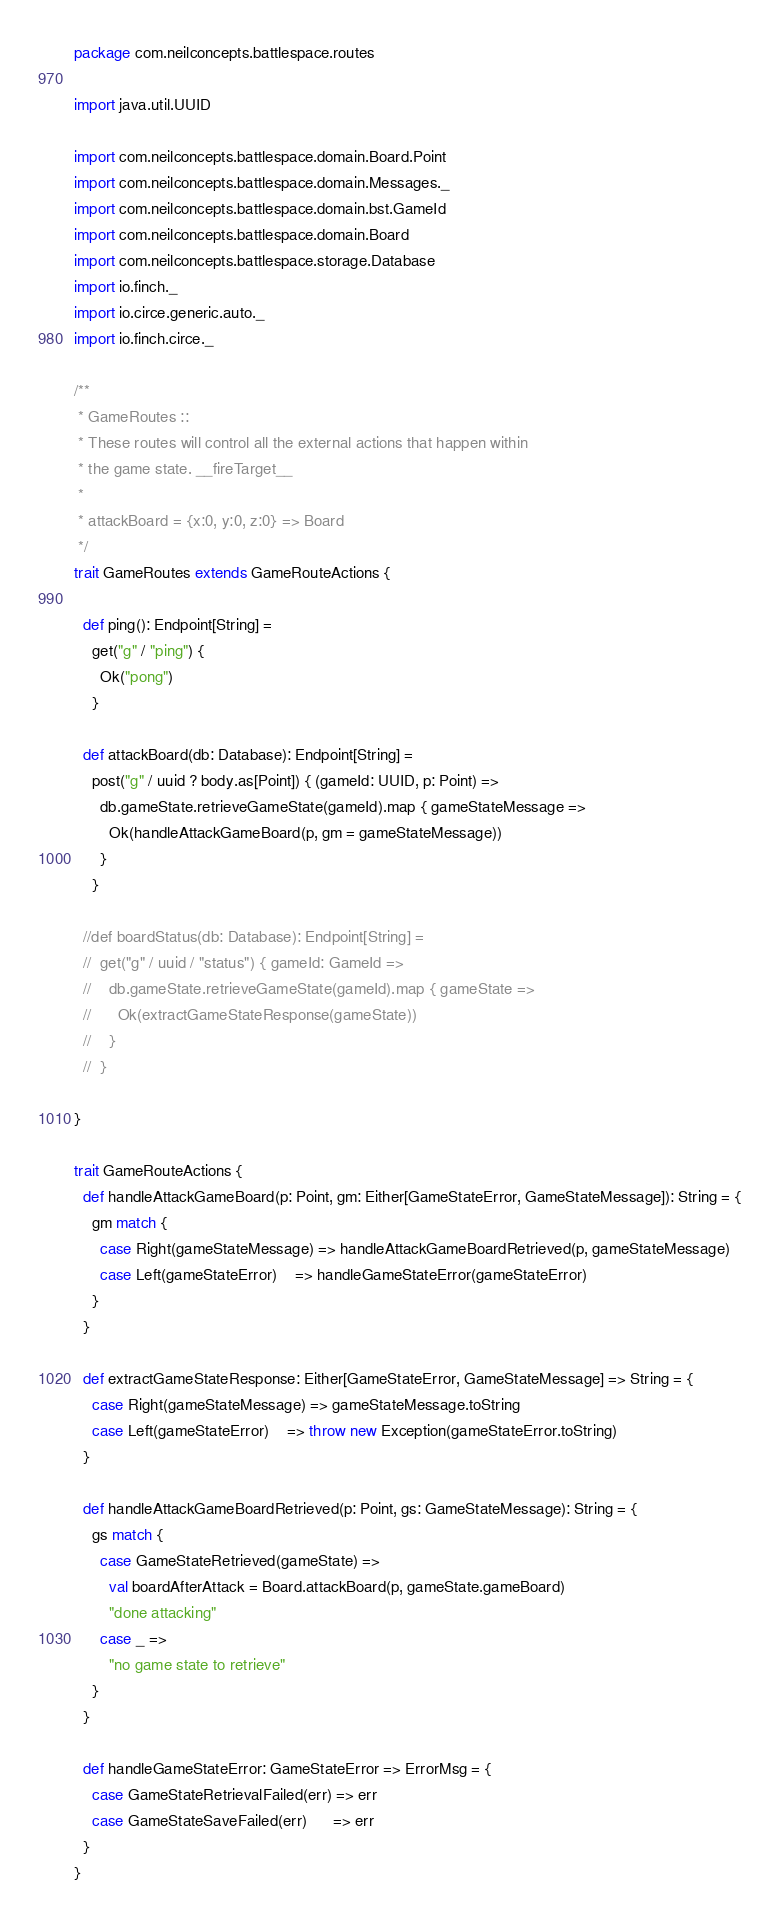Convert code to text. <code><loc_0><loc_0><loc_500><loc_500><_Scala_>package com.neilconcepts.battlespace.routes

import java.util.UUID

import com.neilconcepts.battlespace.domain.Board.Point
import com.neilconcepts.battlespace.domain.Messages._
import com.neilconcepts.battlespace.domain.bst.GameId
import com.neilconcepts.battlespace.domain.Board
import com.neilconcepts.battlespace.storage.Database
import io.finch._
import io.circe.generic.auto._
import io.finch.circe._

/**
 * GameRoutes ::
 * These routes will control all the external actions that happen within
 * the game state. __fireTarget__
 *
 * attackBoard = {x:0, y:0, z:0} => Board
 */
trait GameRoutes extends GameRouteActions {

  def ping(): Endpoint[String] =
    get("g" / "ping") {
      Ok("pong")
    }

  def attackBoard(db: Database): Endpoint[String] =
    post("g" / uuid ? body.as[Point]) { (gameId: UUID, p: Point) =>
      db.gameState.retrieveGameState(gameId).map { gameStateMessage =>
        Ok(handleAttackGameBoard(p, gm = gameStateMessage))
      }
    }

  //def boardStatus(db: Database): Endpoint[String] =
  //  get("g" / uuid / "status") { gameId: GameId =>
  //    db.gameState.retrieveGameState(gameId).map { gameState =>
  //      Ok(extractGameStateResponse(gameState))
  //    }
  //  }

}

trait GameRouteActions {
  def handleAttackGameBoard(p: Point, gm: Either[GameStateError, GameStateMessage]): String = {
    gm match {
      case Right(gameStateMessage) => handleAttackGameBoardRetrieved(p, gameStateMessage)
      case Left(gameStateError)    => handleGameStateError(gameStateError)
    }
  }

  def extractGameStateResponse: Either[GameStateError, GameStateMessage] => String = {
    case Right(gameStateMessage) => gameStateMessage.toString
    case Left(gameStateError)    => throw new Exception(gameStateError.toString)
  }

  def handleAttackGameBoardRetrieved(p: Point, gs: GameStateMessage): String = {
    gs match {
      case GameStateRetrieved(gameState) =>
        val boardAfterAttack = Board.attackBoard(p, gameState.gameBoard)
        "done attacking"
      case _ =>
        "no game state to retrieve"
    }
  }

  def handleGameStateError: GameStateError => ErrorMsg = {
    case GameStateRetrievalFailed(err) => err
    case GameStateSaveFailed(err)      => err
  }
}
</code> 